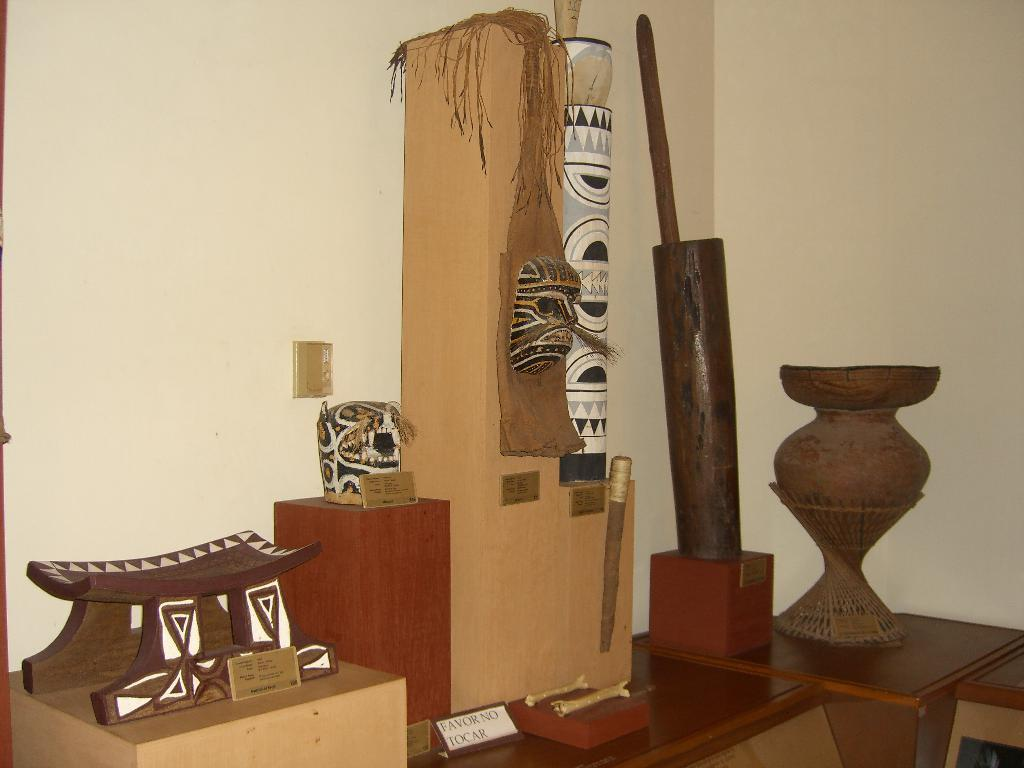What is on the wooden table in the image? There are artifacts on the wooden table. What can be seen in the background of the image? There is a wall in the background of the image. How many friends are sitting on the bed in the image? There is no bed or friends present in the image; it only features a wooden table with artifacts and a wall in the background. 